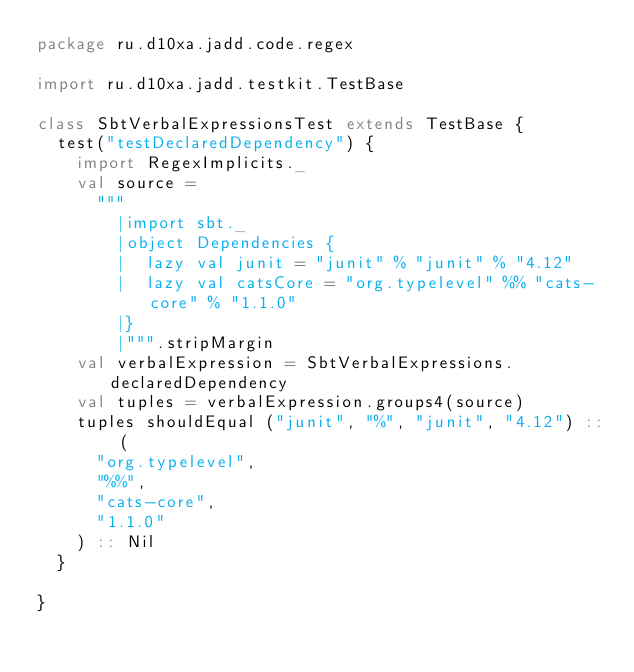<code> <loc_0><loc_0><loc_500><loc_500><_Scala_>package ru.d10xa.jadd.code.regex

import ru.d10xa.jadd.testkit.TestBase

class SbtVerbalExpressionsTest extends TestBase {
  test("testDeclaredDependency") {
    import RegexImplicits._
    val source =
      """
        |import sbt._
        |object Dependencies {
        |  lazy val junit = "junit" % "junit" % "4.12"
        |  lazy val catsCore = "org.typelevel" %% "cats-core" % "1.1.0"
        |}
        |""".stripMargin
    val verbalExpression = SbtVerbalExpressions.declaredDependency
    val tuples = verbalExpression.groups4(source)
    tuples shouldEqual ("junit", "%", "junit", "4.12") :: (
      "org.typelevel",
      "%%",
      "cats-core",
      "1.1.0"
    ) :: Nil
  }

}
</code> 